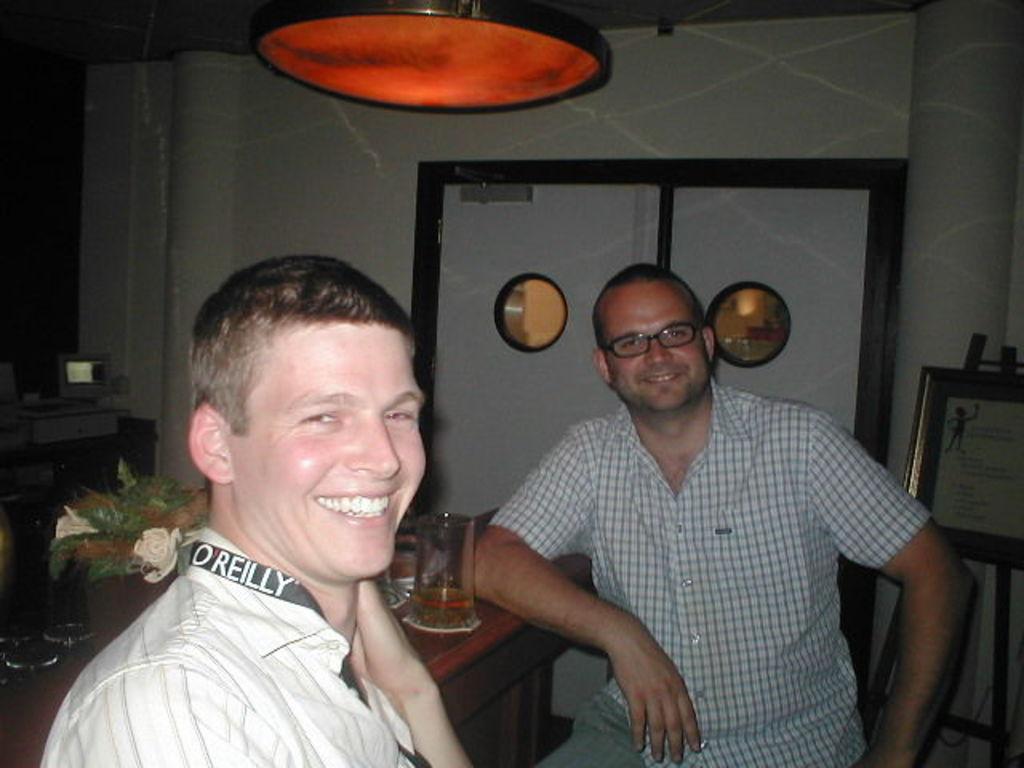How would you summarize this image in a sentence or two? In this picture we can see there are two men. On the left side of the image, there is a table and some objects. On the right side of the image there is a photo frame with a stand. Behind the men there is a door. At the top of the image there is a light. 